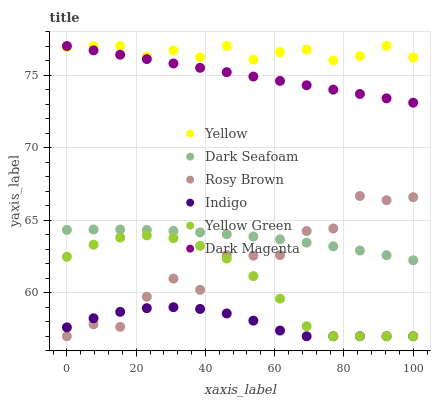Does Indigo have the minimum area under the curve?
Answer yes or no. Yes. Does Yellow have the maximum area under the curve?
Answer yes or no. Yes. Does Yellow Green have the minimum area under the curve?
Answer yes or no. No. Does Yellow Green have the maximum area under the curve?
Answer yes or no. No. Is Dark Magenta the smoothest?
Answer yes or no. Yes. Is Rosy Brown the roughest?
Answer yes or no. Yes. Is Yellow Green the smoothest?
Answer yes or no. No. Is Yellow Green the roughest?
Answer yes or no. No. Does Indigo have the lowest value?
Answer yes or no. Yes. Does Yellow have the lowest value?
Answer yes or no. No. Does Dark Magenta have the highest value?
Answer yes or no. Yes. Does Yellow Green have the highest value?
Answer yes or no. No. Is Yellow Green less than Dark Seafoam?
Answer yes or no. Yes. Is Yellow greater than Rosy Brown?
Answer yes or no. Yes. Does Dark Magenta intersect Yellow?
Answer yes or no. Yes. Is Dark Magenta less than Yellow?
Answer yes or no. No. Is Dark Magenta greater than Yellow?
Answer yes or no. No. Does Yellow Green intersect Dark Seafoam?
Answer yes or no. No. 